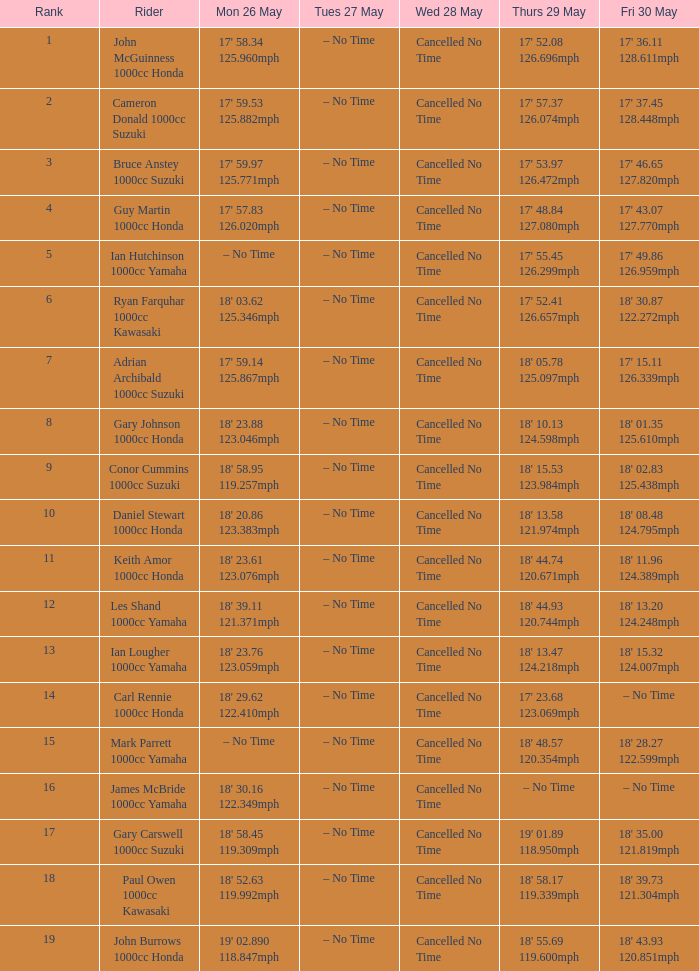What is the numbr for fri may 30 and mon may 26 is 19' 02.890 118.847mph? 18' 43.93 120.851mph. 